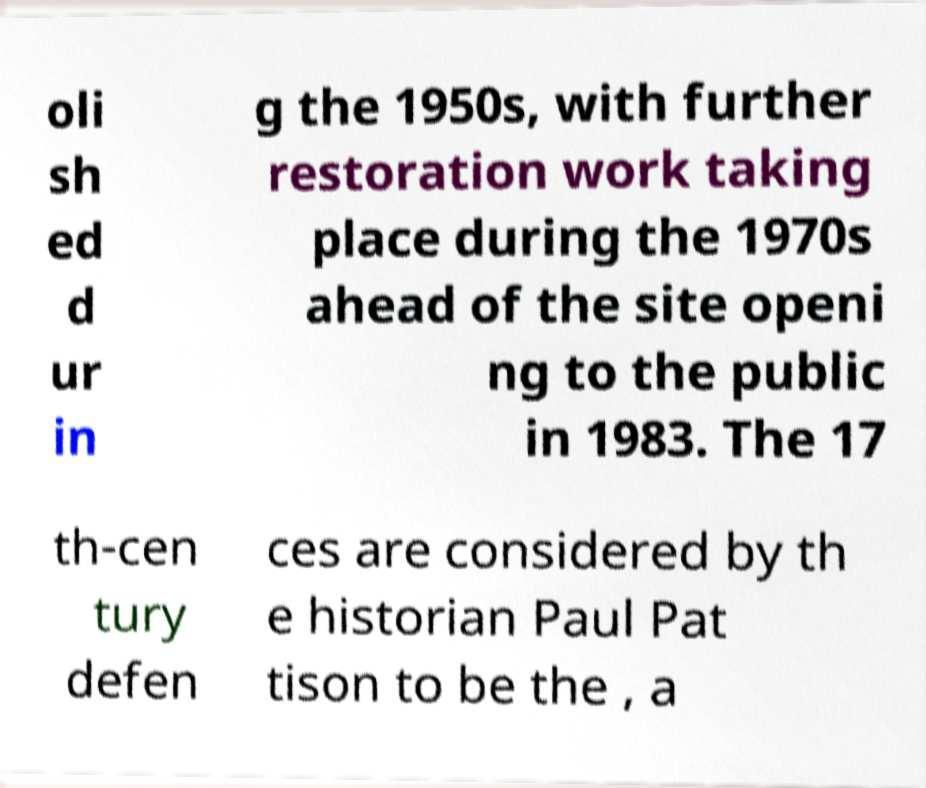What messages or text are displayed in this image? I need them in a readable, typed format. oli sh ed d ur in g the 1950s, with further restoration work taking place during the 1970s ahead of the site openi ng to the public in 1983. The 17 th-cen tury defen ces are considered by th e historian Paul Pat tison to be the , a 